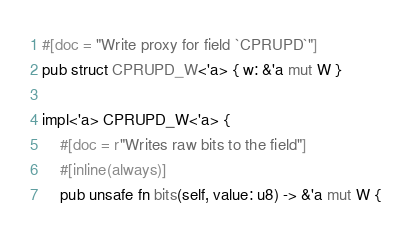Convert code to text. <code><loc_0><loc_0><loc_500><loc_500><_Rust_>
#[doc = "Write proxy for field `CPRUPD`"]
pub struct CPRUPD_W<'a> { w: &'a mut W }

impl<'a> CPRUPD_W<'a> {
    #[doc = r"Writes raw bits to the field"]
    #[inline(always)]
    pub unsafe fn bits(self, value: u8) -> &'a mut W {</code> 